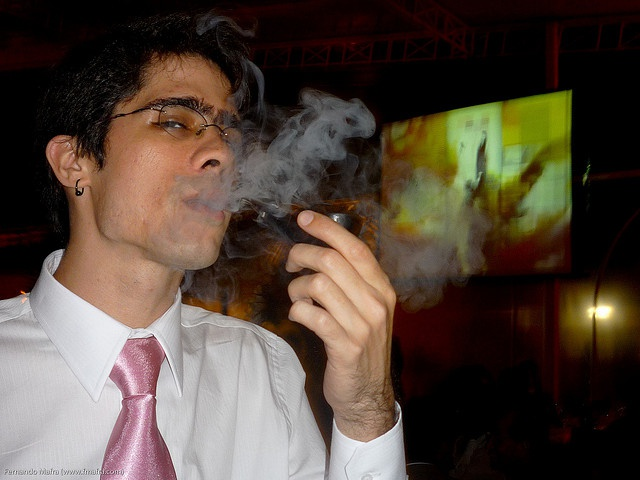Describe the objects in this image and their specific colors. I can see people in black, lightgray, gray, and darkgray tones, tv in black, olive, maroon, and gray tones, and tie in black, brown, gray, and lightpink tones in this image. 